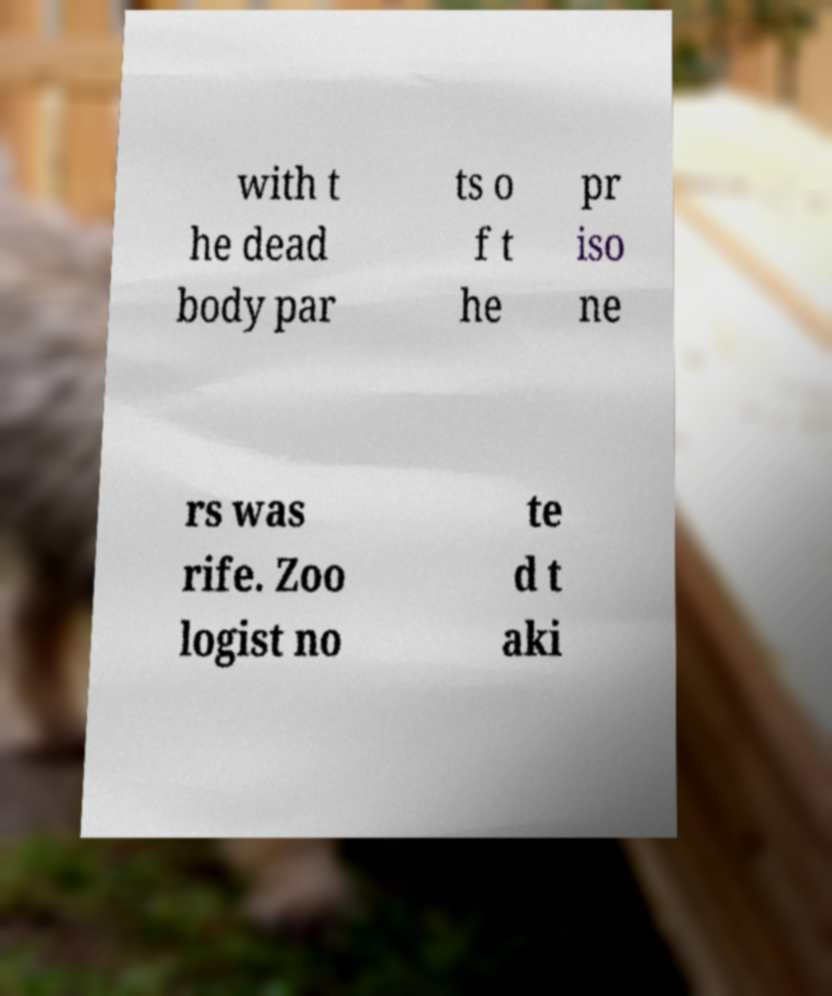What messages or text are displayed in this image? I need them in a readable, typed format. with t he dead body par ts o f t he pr iso ne rs was rife. Zoo logist no te d t aki 